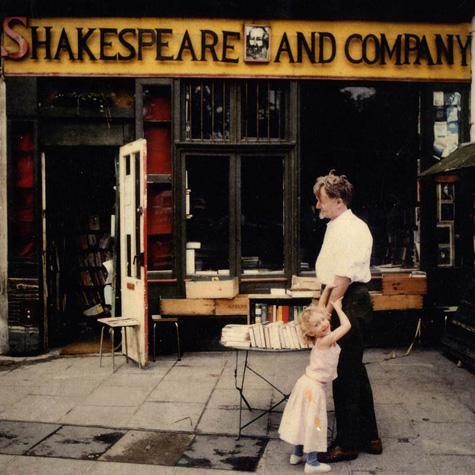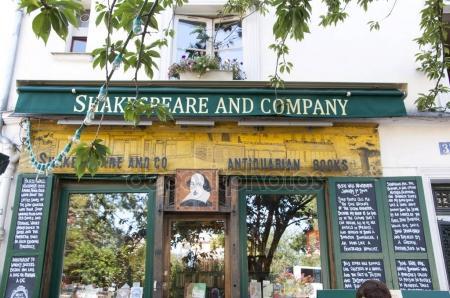The first image is the image on the left, the second image is the image on the right. Evaluate the accuracy of this statement regarding the images: "People are seated outside in a shopping area.". Is it true? Answer yes or no. No. The first image is the image on the left, the second image is the image on the right. Examine the images to the left and right. Is the description "There are people seated." accurate? Answer yes or no. No. 